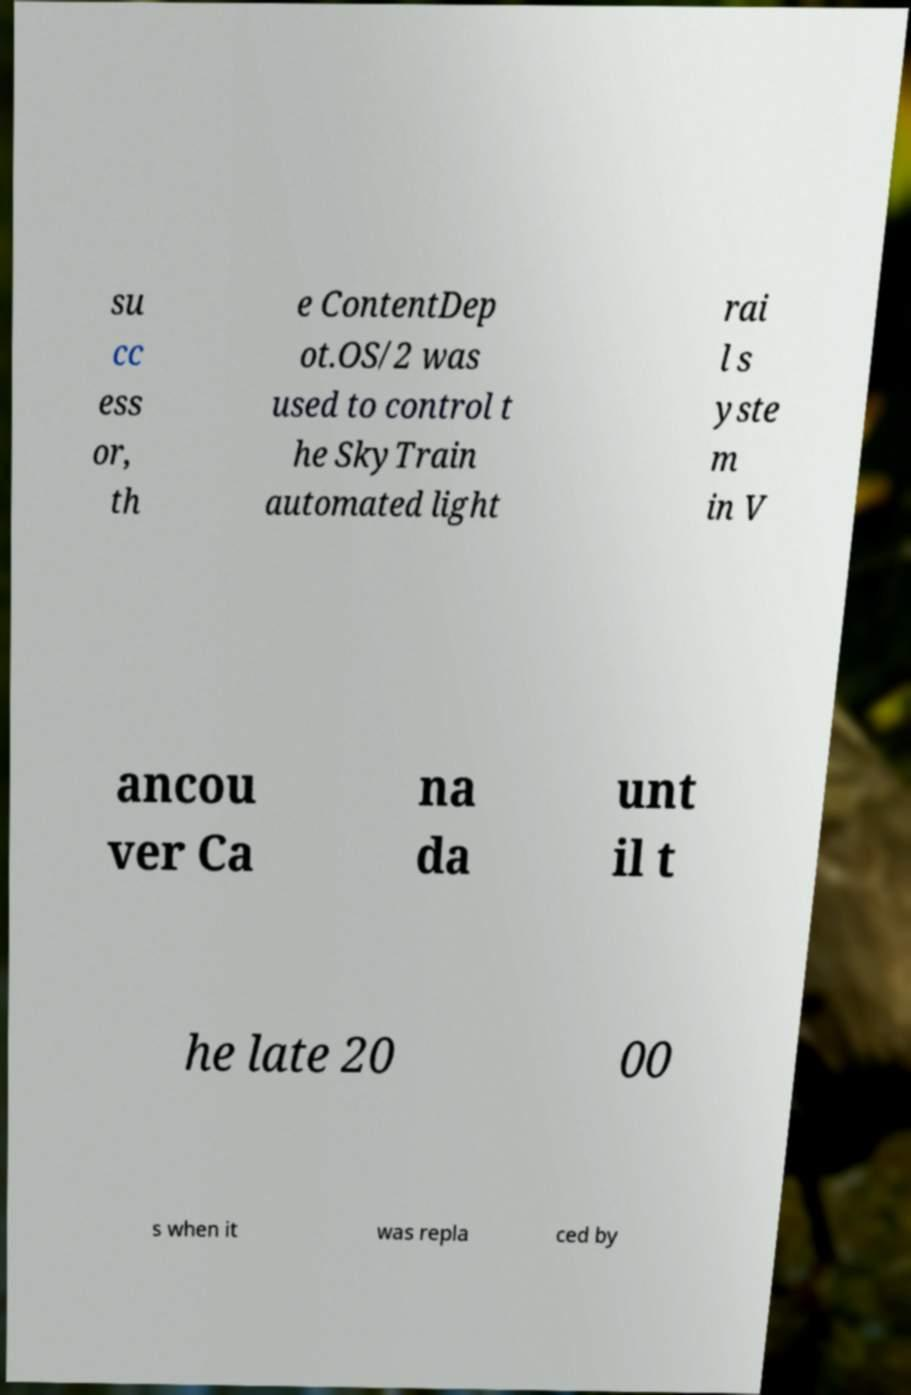What messages or text are displayed in this image? I need them in a readable, typed format. su cc ess or, th e ContentDep ot.OS/2 was used to control t he SkyTrain automated light rai l s yste m in V ancou ver Ca na da unt il t he late 20 00 s when it was repla ced by 